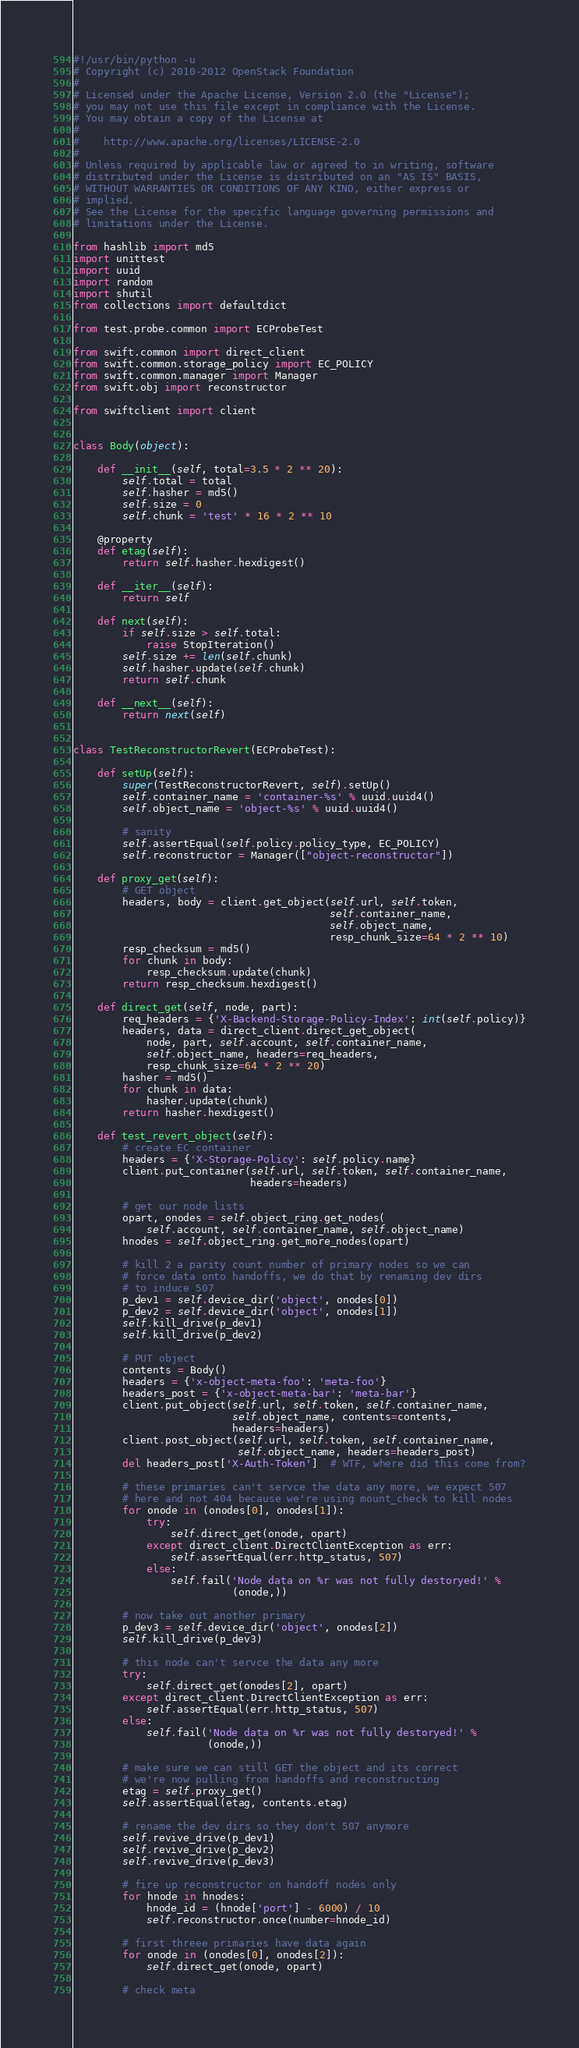Convert code to text. <code><loc_0><loc_0><loc_500><loc_500><_Python_>#!/usr/bin/python -u
# Copyright (c) 2010-2012 OpenStack Foundation
#
# Licensed under the Apache License, Version 2.0 (the "License");
# you may not use this file except in compliance with the License.
# You may obtain a copy of the License at
#
#    http://www.apache.org/licenses/LICENSE-2.0
#
# Unless required by applicable law or agreed to in writing, software
# distributed under the License is distributed on an "AS IS" BASIS,
# WITHOUT WARRANTIES OR CONDITIONS OF ANY KIND, either express or
# implied.
# See the License for the specific language governing permissions and
# limitations under the License.

from hashlib import md5
import unittest
import uuid
import random
import shutil
from collections import defaultdict

from test.probe.common import ECProbeTest

from swift.common import direct_client
from swift.common.storage_policy import EC_POLICY
from swift.common.manager import Manager
from swift.obj import reconstructor

from swiftclient import client


class Body(object):

    def __init__(self, total=3.5 * 2 ** 20):
        self.total = total
        self.hasher = md5()
        self.size = 0
        self.chunk = 'test' * 16 * 2 ** 10

    @property
    def etag(self):
        return self.hasher.hexdigest()

    def __iter__(self):
        return self

    def next(self):
        if self.size > self.total:
            raise StopIteration()
        self.size += len(self.chunk)
        self.hasher.update(self.chunk)
        return self.chunk

    def __next__(self):
        return next(self)


class TestReconstructorRevert(ECProbeTest):

    def setUp(self):
        super(TestReconstructorRevert, self).setUp()
        self.container_name = 'container-%s' % uuid.uuid4()
        self.object_name = 'object-%s' % uuid.uuid4()

        # sanity
        self.assertEqual(self.policy.policy_type, EC_POLICY)
        self.reconstructor = Manager(["object-reconstructor"])

    def proxy_get(self):
        # GET object
        headers, body = client.get_object(self.url, self.token,
                                          self.container_name,
                                          self.object_name,
                                          resp_chunk_size=64 * 2 ** 10)
        resp_checksum = md5()
        for chunk in body:
            resp_checksum.update(chunk)
        return resp_checksum.hexdigest()

    def direct_get(self, node, part):
        req_headers = {'X-Backend-Storage-Policy-Index': int(self.policy)}
        headers, data = direct_client.direct_get_object(
            node, part, self.account, self.container_name,
            self.object_name, headers=req_headers,
            resp_chunk_size=64 * 2 ** 20)
        hasher = md5()
        for chunk in data:
            hasher.update(chunk)
        return hasher.hexdigest()

    def test_revert_object(self):
        # create EC container
        headers = {'X-Storage-Policy': self.policy.name}
        client.put_container(self.url, self.token, self.container_name,
                             headers=headers)

        # get our node lists
        opart, onodes = self.object_ring.get_nodes(
            self.account, self.container_name, self.object_name)
        hnodes = self.object_ring.get_more_nodes(opart)

        # kill 2 a parity count number of primary nodes so we can
        # force data onto handoffs, we do that by renaming dev dirs
        # to induce 507
        p_dev1 = self.device_dir('object', onodes[0])
        p_dev2 = self.device_dir('object', onodes[1])
        self.kill_drive(p_dev1)
        self.kill_drive(p_dev2)

        # PUT object
        contents = Body()
        headers = {'x-object-meta-foo': 'meta-foo'}
        headers_post = {'x-object-meta-bar': 'meta-bar'}
        client.put_object(self.url, self.token, self.container_name,
                          self.object_name, contents=contents,
                          headers=headers)
        client.post_object(self.url, self.token, self.container_name,
                           self.object_name, headers=headers_post)
        del headers_post['X-Auth-Token']  # WTF, where did this come from?

        # these primaries can't servce the data any more, we expect 507
        # here and not 404 because we're using mount_check to kill nodes
        for onode in (onodes[0], onodes[1]):
            try:
                self.direct_get(onode, opart)
            except direct_client.DirectClientException as err:
                self.assertEqual(err.http_status, 507)
            else:
                self.fail('Node data on %r was not fully destoryed!' %
                          (onode,))

        # now take out another primary
        p_dev3 = self.device_dir('object', onodes[2])
        self.kill_drive(p_dev3)

        # this node can't servce the data any more
        try:
            self.direct_get(onodes[2], opart)
        except direct_client.DirectClientException as err:
            self.assertEqual(err.http_status, 507)
        else:
            self.fail('Node data on %r was not fully destoryed!' %
                      (onode,))

        # make sure we can still GET the object and its correct
        # we're now pulling from handoffs and reconstructing
        etag = self.proxy_get()
        self.assertEqual(etag, contents.etag)

        # rename the dev dirs so they don't 507 anymore
        self.revive_drive(p_dev1)
        self.revive_drive(p_dev2)
        self.revive_drive(p_dev3)

        # fire up reconstructor on handoff nodes only
        for hnode in hnodes:
            hnode_id = (hnode['port'] - 6000) / 10
            self.reconstructor.once(number=hnode_id)

        # first threee primaries have data again
        for onode in (onodes[0], onodes[2]):
            self.direct_get(onode, opart)

        # check meta</code> 